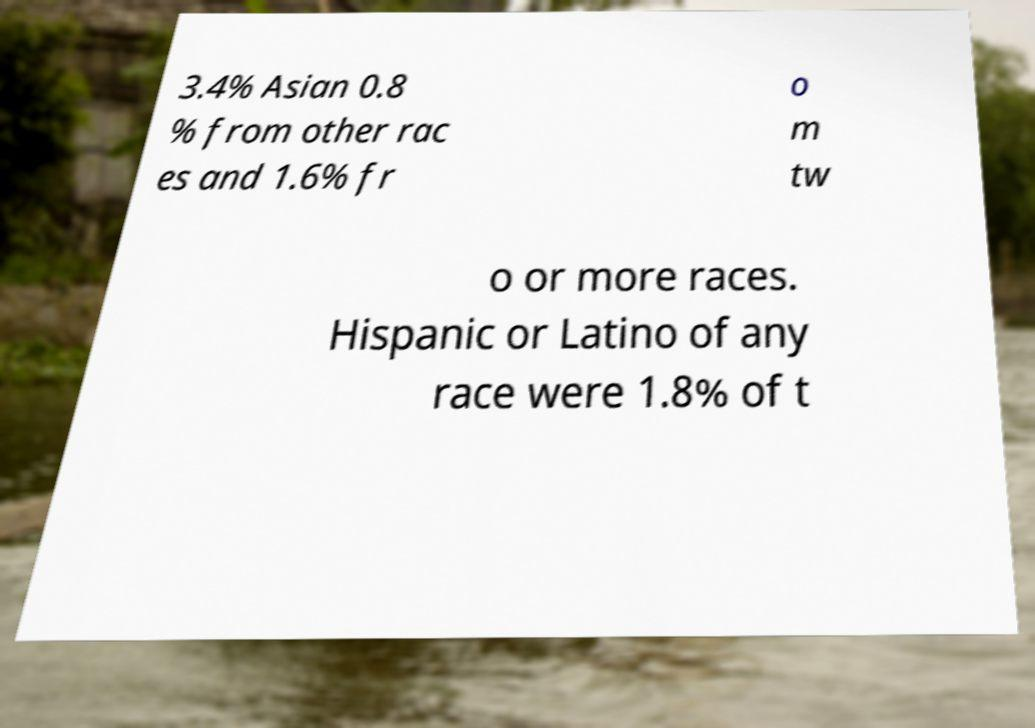Please read and relay the text visible in this image. What does it say? 3.4% Asian 0.8 % from other rac es and 1.6% fr o m tw o or more races. Hispanic or Latino of any race were 1.8% of t 